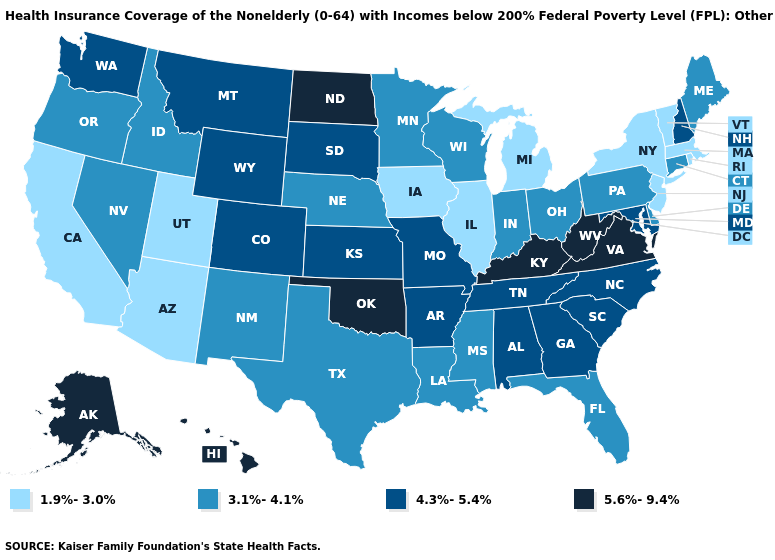What is the value of Kentucky?
Keep it brief. 5.6%-9.4%. Does Iowa have the lowest value in the MidWest?
Answer briefly. Yes. Among the states that border North Carolina , does Virginia have the lowest value?
Concise answer only. No. What is the value of Kansas?
Give a very brief answer. 4.3%-5.4%. Name the states that have a value in the range 3.1%-4.1%?
Concise answer only. Connecticut, Delaware, Florida, Idaho, Indiana, Louisiana, Maine, Minnesota, Mississippi, Nebraska, Nevada, New Mexico, Ohio, Oregon, Pennsylvania, Texas, Wisconsin. Among the states that border New Jersey , does Delaware have the lowest value?
Give a very brief answer. No. What is the value of West Virginia?
Quick response, please. 5.6%-9.4%. What is the highest value in the West ?
Be succinct. 5.6%-9.4%. Which states hav the highest value in the MidWest?
Answer briefly. North Dakota. What is the value of Georgia?
Give a very brief answer. 4.3%-5.4%. Among the states that border Missouri , does Illinois have the lowest value?
Short answer required. Yes. Does Iowa have the highest value in the USA?
Answer briefly. No. What is the value of Kentucky?
Be succinct. 5.6%-9.4%. What is the value of Oregon?
Quick response, please. 3.1%-4.1%. 